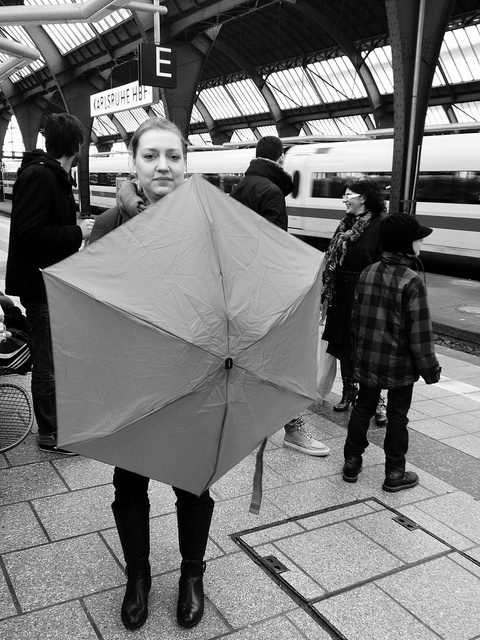Describe the objects in this image and their specific colors. I can see umbrella in black, gray, darkgray, and lightgray tones, people in black, gray, darkgray, and lightgray tones, train in black, white, gray, and darkgray tones, people in black, darkgray, lightgray, and gray tones, and people in black, gray, darkgray, and lightgray tones in this image. 